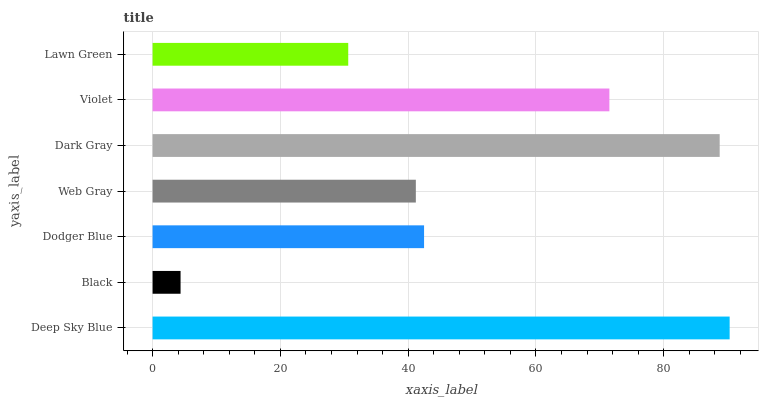Is Black the minimum?
Answer yes or no. Yes. Is Deep Sky Blue the maximum?
Answer yes or no. Yes. Is Dodger Blue the minimum?
Answer yes or no. No. Is Dodger Blue the maximum?
Answer yes or no. No. Is Dodger Blue greater than Black?
Answer yes or no. Yes. Is Black less than Dodger Blue?
Answer yes or no. Yes. Is Black greater than Dodger Blue?
Answer yes or no. No. Is Dodger Blue less than Black?
Answer yes or no. No. Is Dodger Blue the high median?
Answer yes or no. Yes. Is Dodger Blue the low median?
Answer yes or no. Yes. Is Deep Sky Blue the high median?
Answer yes or no. No. Is Web Gray the low median?
Answer yes or no. No. 